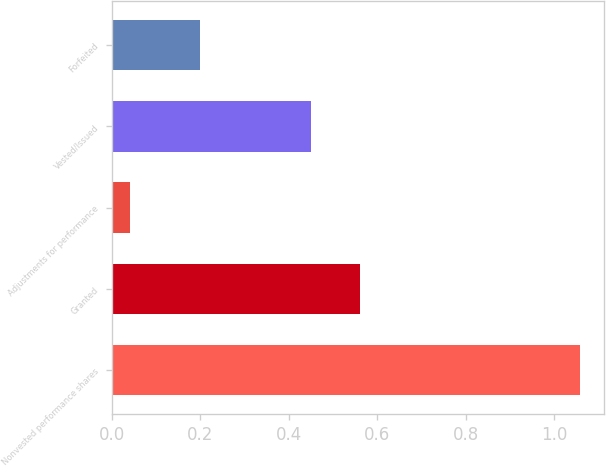Convert chart to OTSL. <chart><loc_0><loc_0><loc_500><loc_500><bar_chart><fcel>Nonvested performance shares<fcel>Granted<fcel>Adjustments for performance<fcel>Vested/Issued<fcel>Forfeited<nl><fcel>1.06<fcel>0.56<fcel>0.04<fcel>0.45<fcel>0.2<nl></chart> 